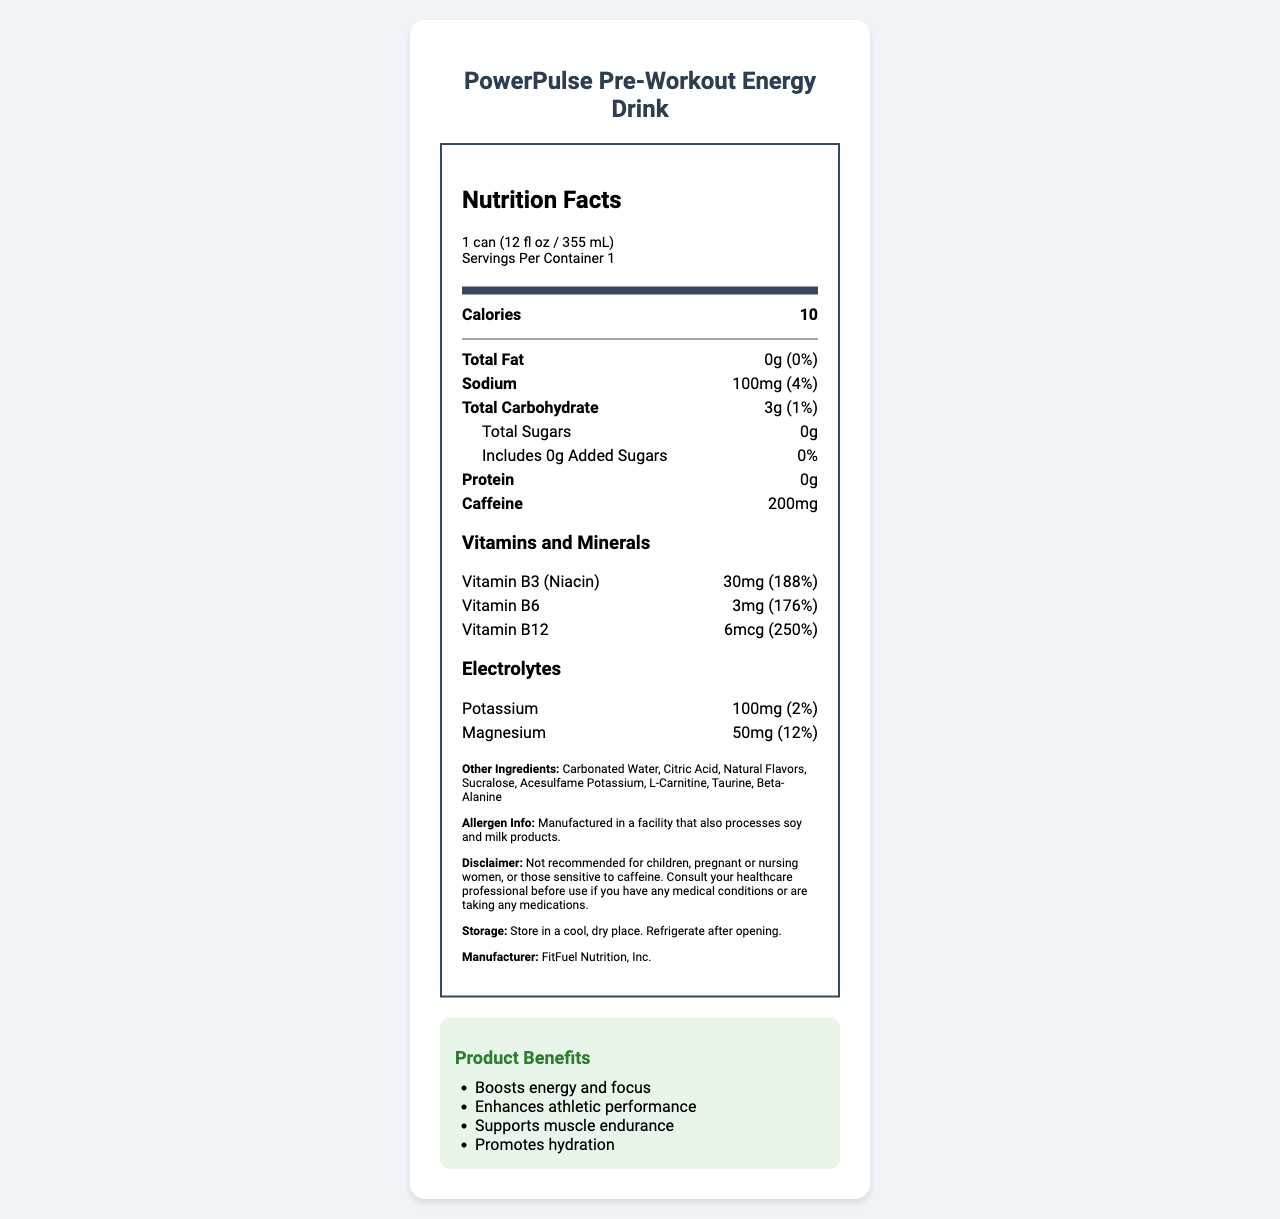what is the serving size for PowerPulse Pre-Workout Energy Drink? The serving size is clearly listed at the top of the document as "1 can (12 fl oz / 355 mL)".
Answer: 1 can (12 fl oz / 355 mL) how much caffeine does one serving of PowerPulse contain? The caffeine content is provided in the document: 200mg per serving.
Answer: 200mg what is the daily value percentage of Vitamin B12 in PowerPulse? The document states that the daily value for Vitamin B12 in one serving is 250%.
Answer: 250% how many grams of protein are in one serving? The document lists the protein content as 0g.
Answer: 0g what is the sodium content in one serving and its daily value percentage? According to the document, the sodium content is 100mg, which is 4% of the daily value.
Answer: 100mg, 4% which of the following is not an ingredient in PowerPulse?
A. Sucralose
B. Stevia
C. Beta-Alanine Sucralose and Beta-Alanine are listed as ingredients, while Stevia is not mentioned.
Answer: B which vitamin has the highest daily value percentage in PowerPulse?
I. Vitamin B3 (Niacin)
II. Vitamin B6
III. Vitamin B12 Vitamin B12 has the highest daily value percentage at 250%, compared to Vitamin B3 at 188% and Vitamin B6 at 176%.
Answer: III is this product recommended for children or pregnant women? (Yes/No) The disclaimer clearly states that the product is not recommended for children, pregnant or nursing women, or those sensitive to caffeine.
Answer: No summarize the key nutritional benefits and usage information of PowerPulse Pre-Workout Energy Drink. The summary includes the main benefits, nutritional content, and usage instructions found in the document.
Answer: PowerPulse Pre-Workout Energy Drink provides a boost in energy and focus, enhances athletic performance, supports muscle endurance, and promotes hydration. It contains 200mg of caffeine and high levels of B-vitamins (B3, B6, B12) and electrolytes (potassium, magnesium). The product is low in calories (10 per serving), contains no sugars or protein, and includes other active ingredients such as L-Carnitine and Beta-Alanine. It's not recommended for children, pregnant women, or individuals sensitive to caffeine and should be stored in a cool, dry place. what is the primary source of sweetness in PowerPulse? The document lists sweeteners such as Sucralose and Acesulfame Potassium, but it does not specify the primary source of sweetness.
Answer: Cannot be determined 